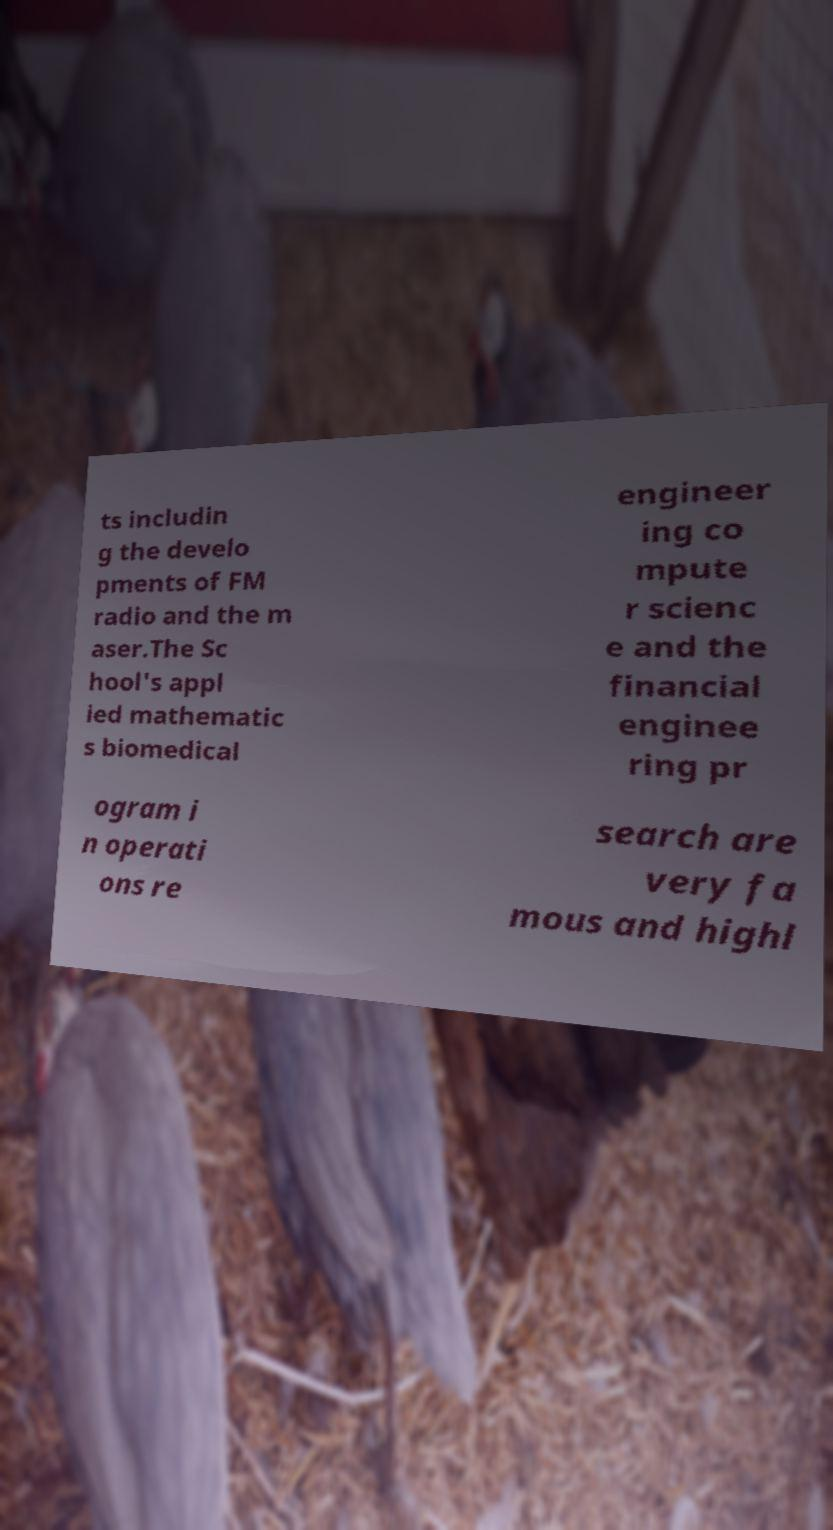Can you read and provide the text displayed in the image?This photo seems to have some interesting text. Can you extract and type it out for me? ts includin g the develo pments of FM radio and the m aser.The Sc hool's appl ied mathematic s biomedical engineer ing co mpute r scienc e and the financial enginee ring pr ogram i n operati ons re search are very fa mous and highl 